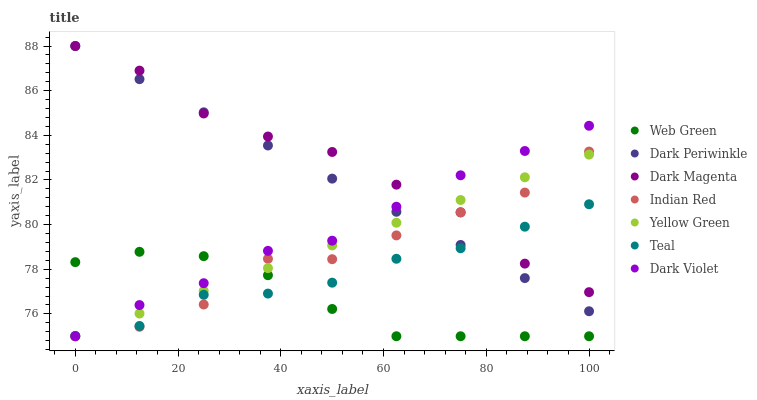Does Web Green have the minimum area under the curve?
Answer yes or no. Yes. Does Dark Magenta have the maximum area under the curve?
Answer yes or no. Yes. Does Yellow Green have the minimum area under the curve?
Answer yes or no. No. Does Yellow Green have the maximum area under the curve?
Answer yes or no. No. Is Yellow Green the smoothest?
Answer yes or no. Yes. Is Indian Red the roughest?
Answer yes or no. Yes. Is Web Green the smoothest?
Answer yes or no. No. Is Web Green the roughest?
Answer yes or no. No. Does Yellow Green have the lowest value?
Answer yes or no. Yes. Does Dark Periwinkle have the lowest value?
Answer yes or no. No. Does Dark Magenta have the highest value?
Answer yes or no. Yes. Does Yellow Green have the highest value?
Answer yes or no. No. Is Web Green less than Dark Periwinkle?
Answer yes or no. Yes. Is Dark Magenta greater than Web Green?
Answer yes or no. Yes. Does Indian Red intersect Dark Magenta?
Answer yes or no. Yes. Is Indian Red less than Dark Magenta?
Answer yes or no. No. Is Indian Red greater than Dark Magenta?
Answer yes or no. No. Does Web Green intersect Dark Periwinkle?
Answer yes or no. No. 